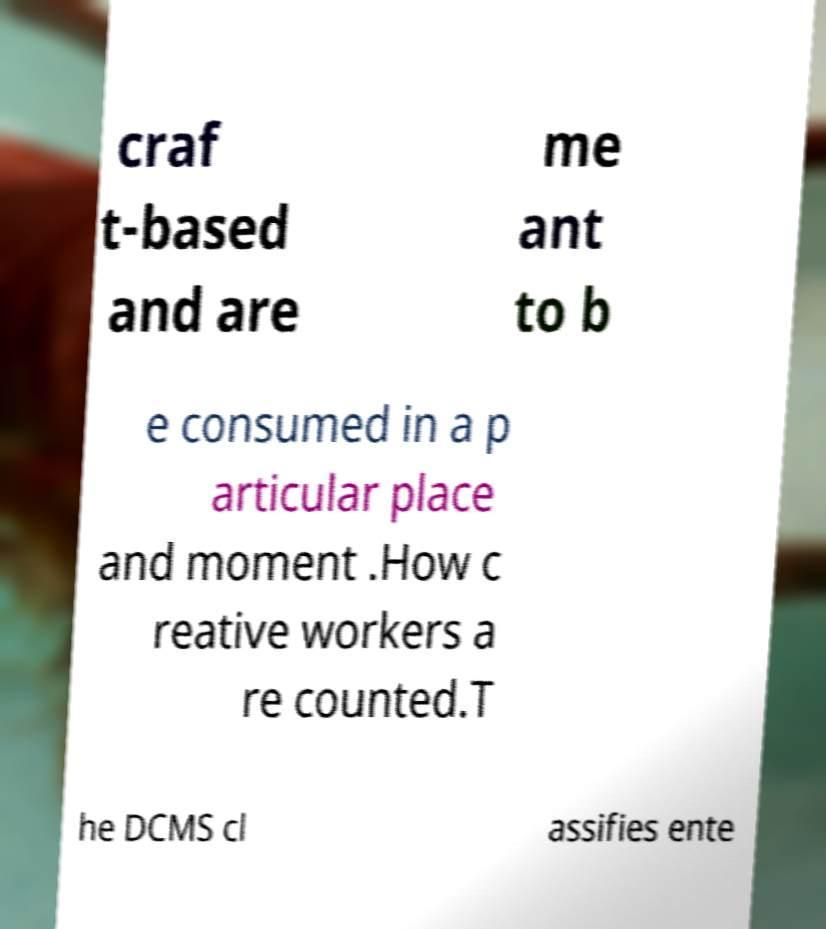Please read and relay the text visible in this image. What does it say? craf t-based and are me ant to b e consumed in a p articular place and moment .How c reative workers a re counted.T he DCMS cl assifies ente 